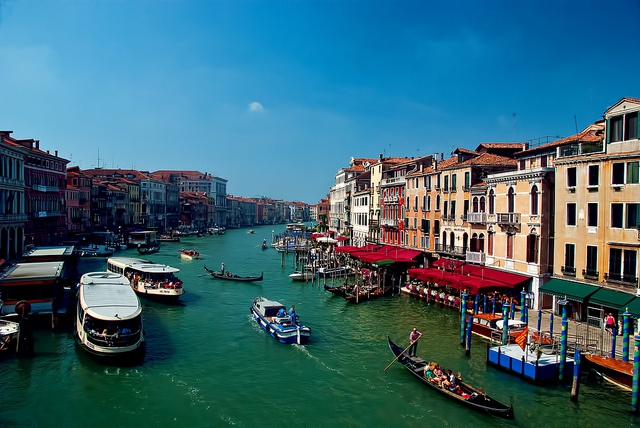Describe the objects in this image and their specific colors. I can see boat in lightblue, black, lightgray, and darkgray tones, boat in lightblue, black, gray, maroon, and teal tones, boat in lightblue, black, ivory, darkgray, and gray tones, boat in lightblue, black, navy, teal, and lightgray tones, and boat in lightblue, black, teal, gray, and darkblue tones in this image. 